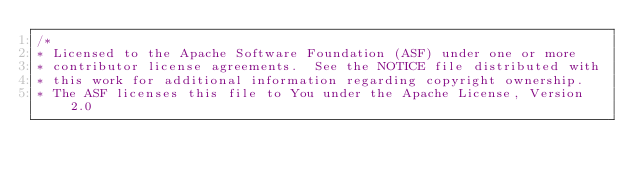<code> <loc_0><loc_0><loc_500><loc_500><_Scala_>/*
* Licensed to the Apache Software Foundation (ASF) under one or more
* contributor license agreements.  See the NOTICE file distributed with
* this work for additional information regarding copyright ownership.
* The ASF licenses this file to You under the Apache License, Version 2.0</code> 